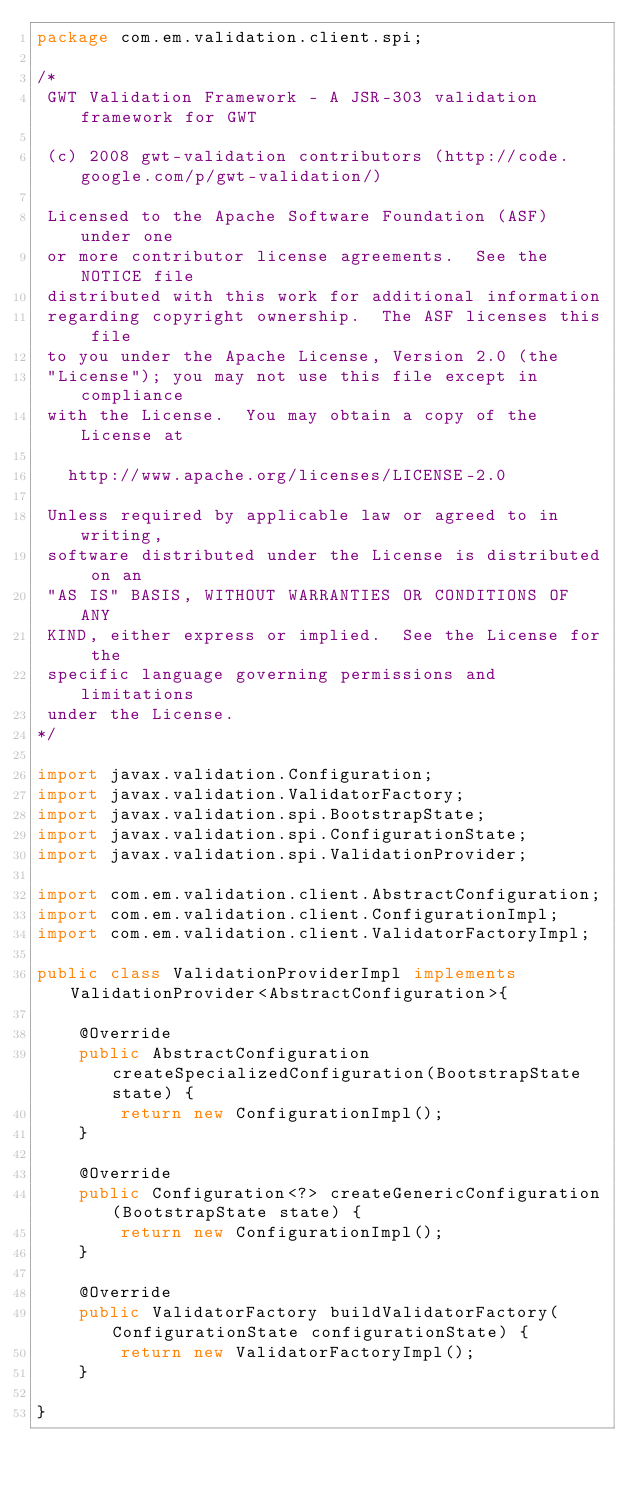Convert code to text. <code><loc_0><loc_0><loc_500><loc_500><_Java_>package com.em.validation.client.spi;

/*
 GWT Validation Framework - A JSR-303 validation framework for GWT

 (c) 2008 gwt-validation contributors (http://code.google.com/p/gwt-validation/) 

 Licensed to the Apache Software Foundation (ASF) under one
 or more contributor license agreements.  See the NOTICE file
 distributed with this work for additional information
 regarding copyright ownership.  The ASF licenses this file
 to you under the Apache License, Version 2.0 (the
 "License"); you may not use this file except in compliance
 with the License.  You may obtain a copy of the License at

   http://www.apache.org/licenses/LICENSE-2.0

 Unless required by applicable law or agreed to in writing,
 software distributed under the License is distributed on an
 "AS IS" BASIS, WITHOUT WARRANTIES OR CONDITIONS OF ANY
 KIND, either express or implied.  See the License for the
 specific language governing permissions and limitations
 under the License.
*/

import javax.validation.Configuration;
import javax.validation.ValidatorFactory;
import javax.validation.spi.BootstrapState;
import javax.validation.spi.ConfigurationState;
import javax.validation.spi.ValidationProvider;

import com.em.validation.client.AbstractConfiguration;
import com.em.validation.client.ConfigurationImpl;
import com.em.validation.client.ValidatorFactoryImpl;

public class ValidationProviderImpl implements ValidationProvider<AbstractConfiguration>{

	@Override
	public AbstractConfiguration createSpecializedConfiguration(BootstrapState state) {
		return new ConfigurationImpl();
	}

	@Override
	public Configuration<?> createGenericConfiguration(BootstrapState state) {
		return new ConfigurationImpl();
	}

	@Override
	public ValidatorFactory buildValidatorFactory(ConfigurationState configurationState) {
		return new ValidatorFactoryImpl();
	}

}
</code> 